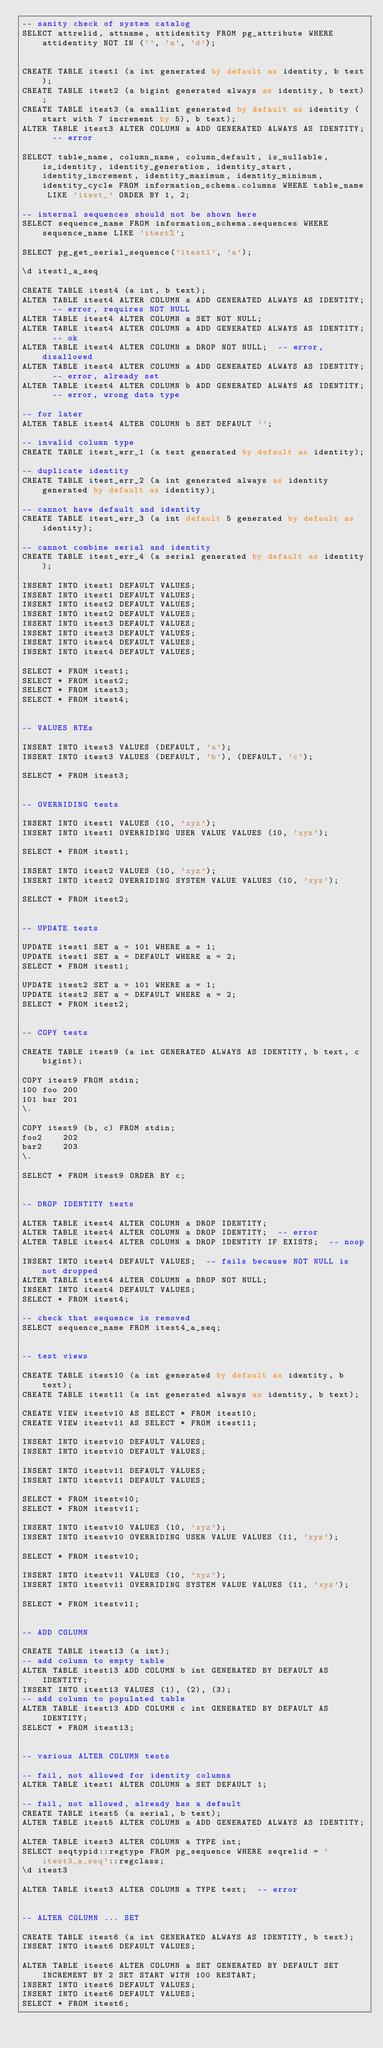<code> <loc_0><loc_0><loc_500><loc_500><_SQL_>-- sanity check of system catalog
SELECT attrelid, attname, attidentity FROM pg_attribute WHERE attidentity NOT IN ('', 'a', 'd');


CREATE TABLE itest1 (a int generated by default as identity, b text);
CREATE TABLE itest2 (a bigint generated always as identity, b text);
CREATE TABLE itest3 (a smallint generated by default as identity (start with 7 increment by 5), b text);
ALTER TABLE itest3 ALTER COLUMN a ADD GENERATED ALWAYS AS IDENTITY;  -- error

SELECT table_name, column_name, column_default, is_nullable, is_identity, identity_generation, identity_start, identity_increment, identity_maximum, identity_minimum, identity_cycle FROM information_schema.columns WHERE table_name LIKE 'itest_' ORDER BY 1, 2;

-- internal sequences should not be shown here
SELECT sequence_name FROM information_schema.sequences WHERE sequence_name LIKE 'itest%';

SELECT pg_get_serial_sequence('itest1', 'a');

\d itest1_a_seq

CREATE TABLE itest4 (a int, b text);
ALTER TABLE itest4 ALTER COLUMN a ADD GENERATED ALWAYS AS IDENTITY;  -- error, requires NOT NULL
ALTER TABLE itest4 ALTER COLUMN a SET NOT NULL;
ALTER TABLE itest4 ALTER COLUMN a ADD GENERATED ALWAYS AS IDENTITY;  -- ok
ALTER TABLE itest4 ALTER COLUMN a DROP NOT NULL;  -- error, disallowed
ALTER TABLE itest4 ALTER COLUMN a ADD GENERATED ALWAYS AS IDENTITY;  -- error, already set
ALTER TABLE itest4 ALTER COLUMN b ADD GENERATED ALWAYS AS IDENTITY;  -- error, wrong data type

-- for later
ALTER TABLE itest4 ALTER COLUMN b SET DEFAULT '';

-- invalid column type
CREATE TABLE itest_err_1 (a text generated by default as identity);

-- duplicate identity
CREATE TABLE itest_err_2 (a int generated always as identity generated by default as identity);

-- cannot have default and identity
CREATE TABLE itest_err_3 (a int default 5 generated by default as identity);

-- cannot combine serial and identity
CREATE TABLE itest_err_4 (a serial generated by default as identity);

INSERT INTO itest1 DEFAULT VALUES;
INSERT INTO itest1 DEFAULT VALUES;
INSERT INTO itest2 DEFAULT VALUES;
INSERT INTO itest2 DEFAULT VALUES;
INSERT INTO itest3 DEFAULT VALUES;
INSERT INTO itest3 DEFAULT VALUES;
INSERT INTO itest4 DEFAULT VALUES;
INSERT INTO itest4 DEFAULT VALUES;

SELECT * FROM itest1;
SELECT * FROM itest2;
SELECT * FROM itest3;
SELECT * FROM itest4;


-- VALUES RTEs

INSERT INTO itest3 VALUES (DEFAULT, 'a');
INSERT INTO itest3 VALUES (DEFAULT, 'b'), (DEFAULT, 'c');

SELECT * FROM itest3;


-- OVERRIDING tests

INSERT INTO itest1 VALUES (10, 'xyz');
INSERT INTO itest1 OVERRIDING USER VALUE VALUES (10, 'xyz');

SELECT * FROM itest1;

INSERT INTO itest2 VALUES (10, 'xyz');
INSERT INTO itest2 OVERRIDING SYSTEM VALUE VALUES (10, 'xyz');

SELECT * FROM itest2;


-- UPDATE tests

UPDATE itest1 SET a = 101 WHERE a = 1;
UPDATE itest1 SET a = DEFAULT WHERE a = 2;
SELECT * FROM itest1;

UPDATE itest2 SET a = 101 WHERE a = 1;
UPDATE itest2 SET a = DEFAULT WHERE a = 2;
SELECT * FROM itest2;


-- COPY tests

CREATE TABLE itest9 (a int GENERATED ALWAYS AS IDENTITY, b text, c bigint);

COPY itest9 FROM stdin;
100	foo	200
101	bar	201
\.

COPY itest9 (b, c) FROM stdin;
foo2	202
bar2	203
\.

SELECT * FROM itest9 ORDER BY c;


-- DROP IDENTITY tests

ALTER TABLE itest4 ALTER COLUMN a DROP IDENTITY;
ALTER TABLE itest4 ALTER COLUMN a DROP IDENTITY;  -- error
ALTER TABLE itest4 ALTER COLUMN a DROP IDENTITY IF EXISTS;  -- noop

INSERT INTO itest4 DEFAULT VALUES;  -- fails because NOT NULL is not dropped
ALTER TABLE itest4 ALTER COLUMN a DROP NOT NULL;
INSERT INTO itest4 DEFAULT VALUES;
SELECT * FROM itest4;

-- check that sequence is removed
SELECT sequence_name FROM itest4_a_seq;


-- test views

CREATE TABLE itest10 (a int generated by default as identity, b text);
CREATE TABLE itest11 (a int generated always as identity, b text);

CREATE VIEW itestv10 AS SELECT * FROM itest10;
CREATE VIEW itestv11 AS SELECT * FROM itest11;

INSERT INTO itestv10 DEFAULT VALUES;
INSERT INTO itestv10 DEFAULT VALUES;

INSERT INTO itestv11 DEFAULT VALUES;
INSERT INTO itestv11 DEFAULT VALUES;

SELECT * FROM itestv10;
SELECT * FROM itestv11;

INSERT INTO itestv10 VALUES (10, 'xyz');
INSERT INTO itestv10 OVERRIDING USER VALUE VALUES (11, 'xyz');

SELECT * FROM itestv10;

INSERT INTO itestv11 VALUES (10, 'xyz');
INSERT INTO itestv11 OVERRIDING SYSTEM VALUE VALUES (11, 'xyz');

SELECT * FROM itestv11;


-- ADD COLUMN

CREATE TABLE itest13 (a int);
-- add column to empty table
ALTER TABLE itest13 ADD COLUMN b int GENERATED BY DEFAULT AS IDENTITY;
INSERT INTO itest13 VALUES (1), (2), (3);
-- add column to populated table
ALTER TABLE itest13 ADD COLUMN c int GENERATED BY DEFAULT AS IDENTITY;
SELECT * FROM itest13;


-- various ALTER COLUMN tests

-- fail, not allowed for identity columns
ALTER TABLE itest1 ALTER COLUMN a SET DEFAULT 1;

-- fail, not allowed, already has a default
CREATE TABLE itest5 (a serial, b text);
ALTER TABLE itest5 ALTER COLUMN a ADD GENERATED ALWAYS AS IDENTITY;

ALTER TABLE itest3 ALTER COLUMN a TYPE int;
SELECT seqtypid::regtype FROM pg_sequence WHERE seqrelid = 'itest3_a_seq'::regclass;
\d itest3

ALTER TABLE itest3 ALTER COLUMN a TYPE text;  -- error


-- ALTER COLUMN ... SET

CREATE TABLE itest6 (a int GENERATED ALWAYS AS IDENTITY, b text);
INSERT INTO itest6 DEFAULT VALUES;

ALTER TABLE itest6 ALTER COLUMN a SET GENERATED BY DEFAULT SET INCREMENT BY 2 SET START WITH 100 RESTART;
INSERT INTO itest6 DEFAULT VALUES;
INSERT INTO itest6 DEFAULT VALUES;
SELECT * FROM itest6;
</code> 